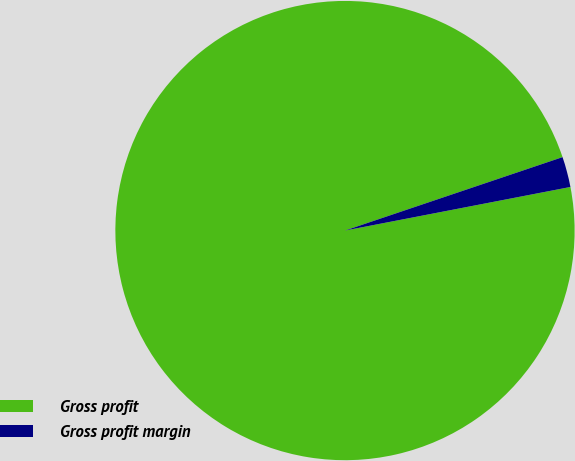Convert chart. <chart><loc_0><loc_0><loc_500><loc_500><pie_chart><fcel>Gross profit<fcel>Gross profit margin<nl><fcel>97.86%<fcel>2.14%<nl></chart> 